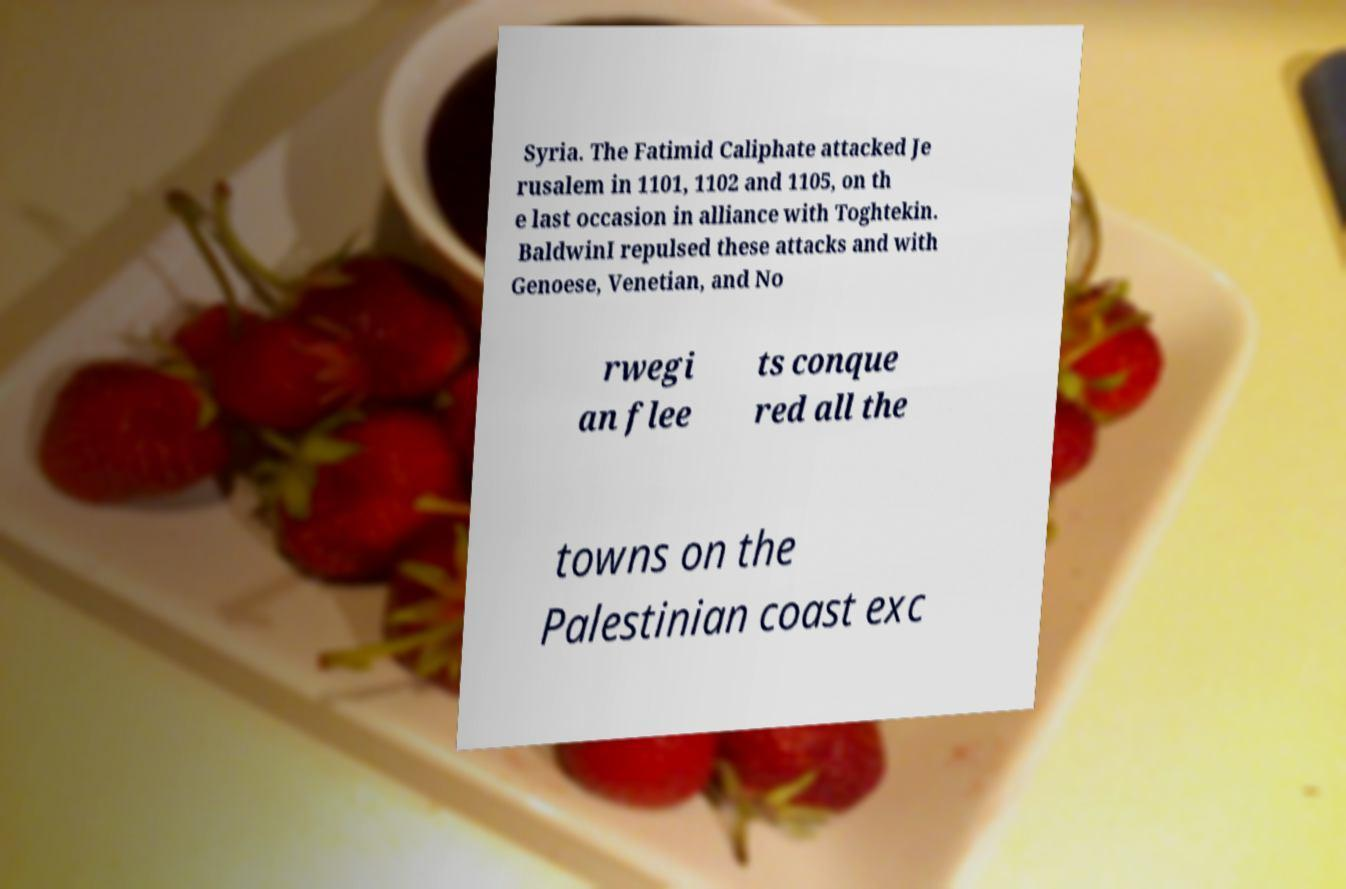Can you read and provide the text displayed in the image?This photo seems to have some interesting text. Can you extract and type it out for me? Syria. The Fatimid Caliphate attacked Je rusalem in 1101, 1102 and 1105, on th e last occasion in alliance with Toghtekin. BaldwinI repulsed these attacks and with Genoese, Venetian, and No rwegi an flee ts conque red all the towns on the Palestinian coast exc 